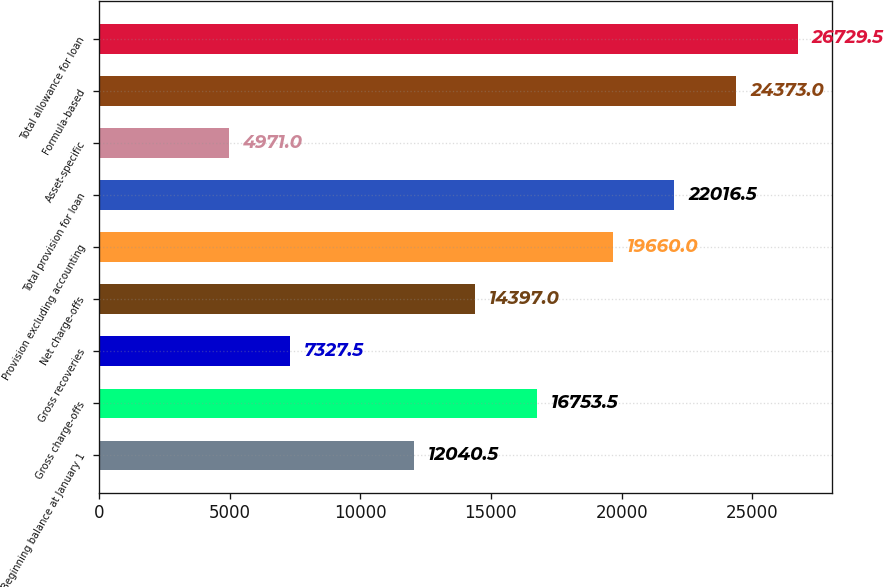Convert chart. <chart><loc_0><loc_0><loc_500><loc_500><bar_chart><fcel>Beginning balance at January 1<fcel>Gross charge-offs<fcel>Gross recoveries<fcel>Net charge-offs<fcel>Provision excluding accounting<fcel>Total provision for loan<fcel>Asset-specific<fcel>Formula-based<fcel>Total allowance for loan<nl><fcel>12040.5<fcel>16753.5<fcel>7327.5<fcel>14397<fcel>19660<fcel>22016.5<fcel>4971<fcel>24373<fcel>26729.5<nl></chart> 